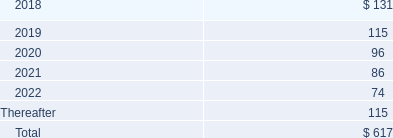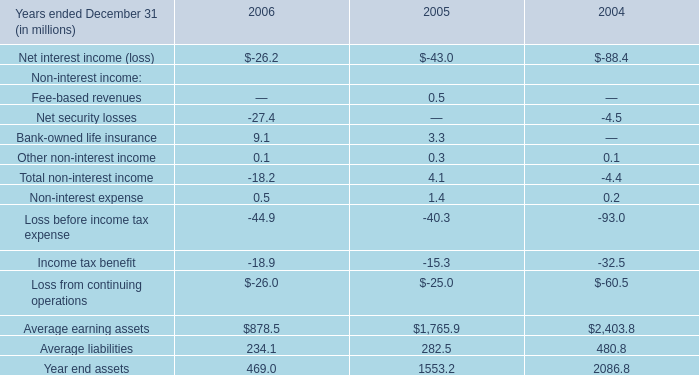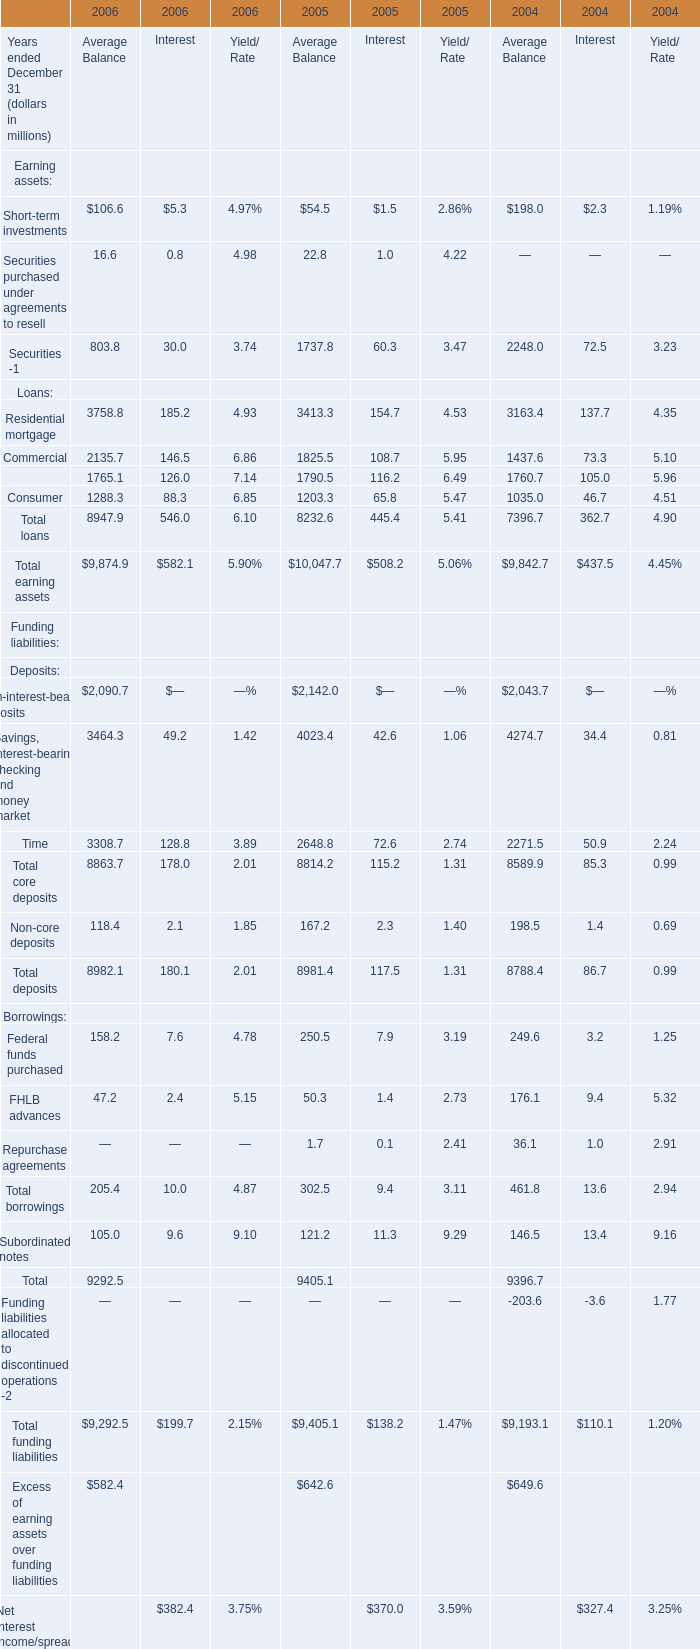In the year with largest amount of Average Balance of Total earning assets, what's the increasing rate of Average Balance of Total loans? 
Computations: ((8232.6 - 7396.7) / 7396.7)
Answer: 0.11301. 